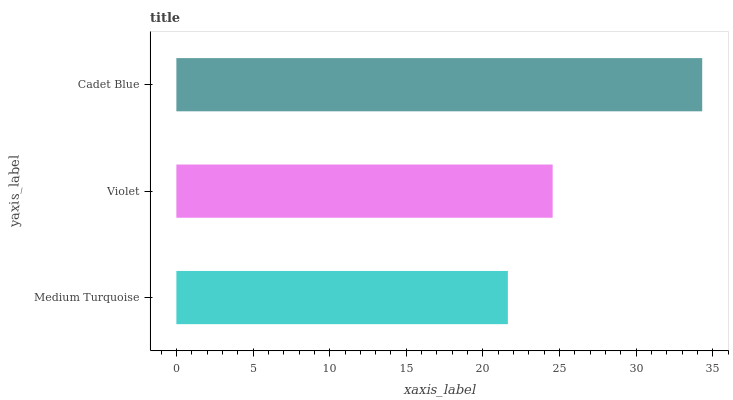Is Medium Turquoise the minimum?
Answer yes or no. Yes. Is Cadet Blue the maximum?
Answer yes or no. Yes. Is Violet the minimum?
Answer yes or no. No. Is Violet the maximum?
Answer yes or no. No. Is Violet greater than Medium Turquoise?
Answer yes or no. Yes. Is Medium Turquoise less than Violet?
Answer yes or no. Yes. Is Medium Turquoise greater than Violet?
Answer yes or no. No. Is Violet less than Medium Turquoise?
Answer yes or no. No. Is Violet the high median?
Answer yes or no. Yes. Is Violet the low median?
Answer yes or no. Yes. Is Cadet Blue the high median?
Answer yes or no. No. Is Medium Turquoise the low median?
Answer yes or no. No. 